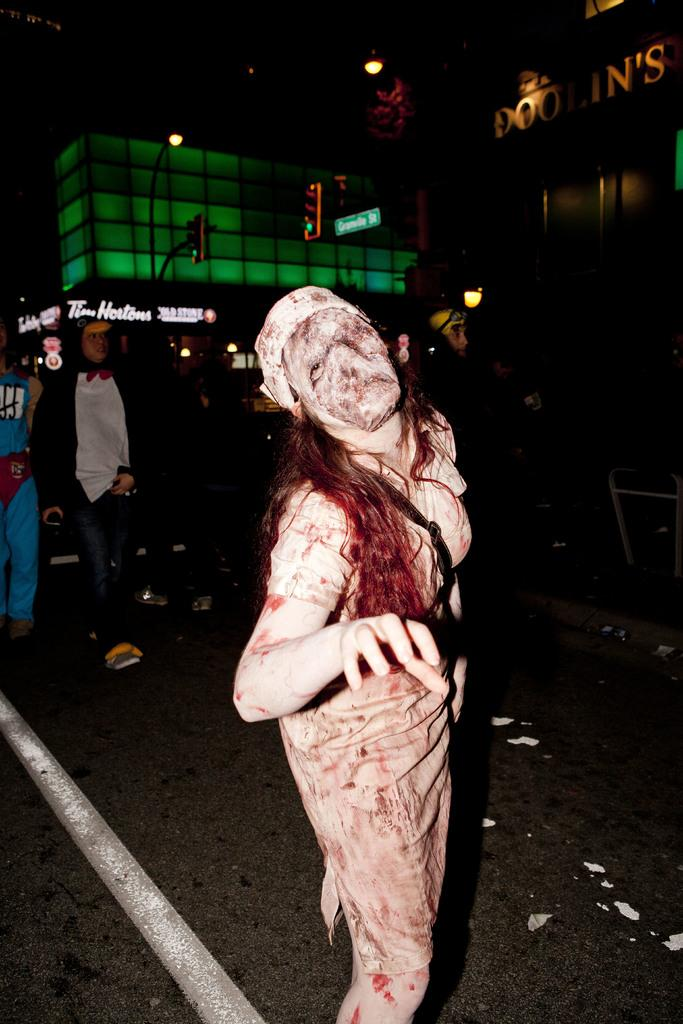What is the main subject in the center of the picture? There is a woman in the center of the picture wearing a different costume. What can be seen in the background of the image? In the background, there are people walking on the road, buildings, lights, and other objects. Can you describe the woman's attire in the image? The woman is wearing a different costume. Is your aunt smashing a plant in the image? There is no mention of an aunt or a plant being smashed in the image. 